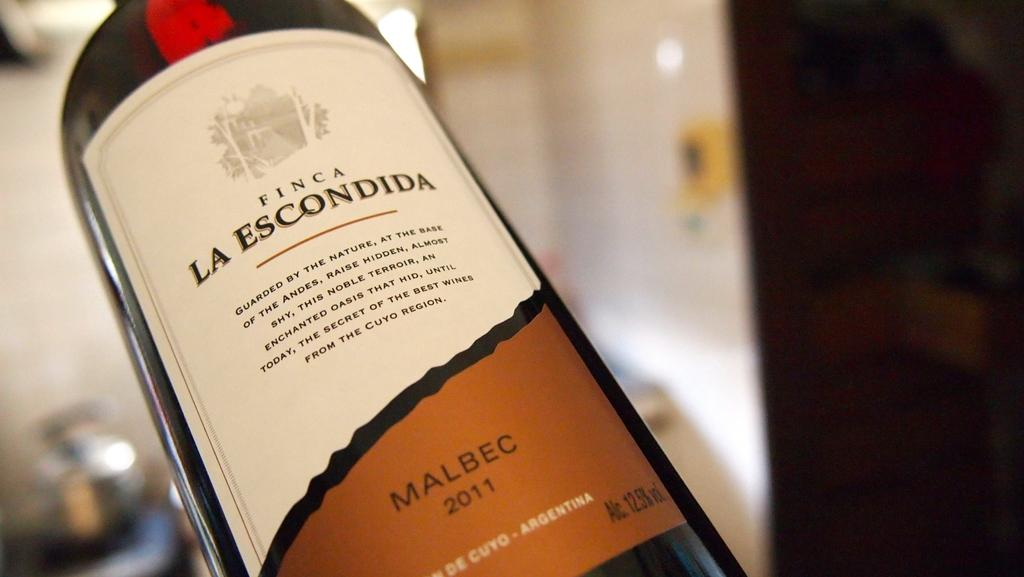<image>
Offer a succinct explanation of the picture presented. A full bottle of Finca La Escondida 2011. 